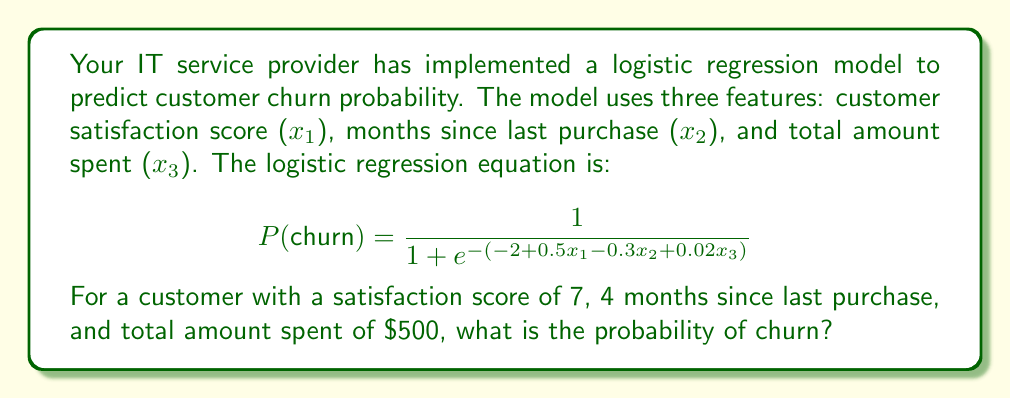Can you solve this math problem? To solve this problem, we need to follow these steps:

1. Identify the values for each feature:
   $x_1$ (satisfaction score) = 7
   $x_2$ (months since last purchase) = 4
   $x_3$ (total amount spent) = 500

2. Substitute these values into the logistic regression equation:

   $$ P(churn) = \frac{1}{1 + e^{-(-2 + 0.5x_1 - 0.3x_2 + 0.02x_3)}} $$

3. Calculate the exponent:
   $-2 + 0.5(7) - 0.3(4) + 0.02(500)$
   $= -2 + 3.5 - 1.2 + 10$
   $= 10.3$

4. Simplify the equation:
   $$ P(churn) = \frac{1}{1 + e^{-10.3}} $$

5. Calculate $e^{-10.3}$:
   $e^{-10.3} \approx 0.0000336$

6. Substitute this value and solve:
   $$ P(churn) = \frac{1}{1 + 0.0000336} \approx 0.9999664 $$

7. Convert to a percentage:
   0.9999664 * 100% ≈ 99.99664%
Answer: The probability of churn for this customer is approximately 99.99664%. 